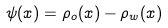Convert formula to latex. <formula><loc_0><loc_0><loc_500><loc_500>\psi ( { x } ) = \rho _ { o } ( { x } ) - \rho _ { w } ( { x } )</formula> 